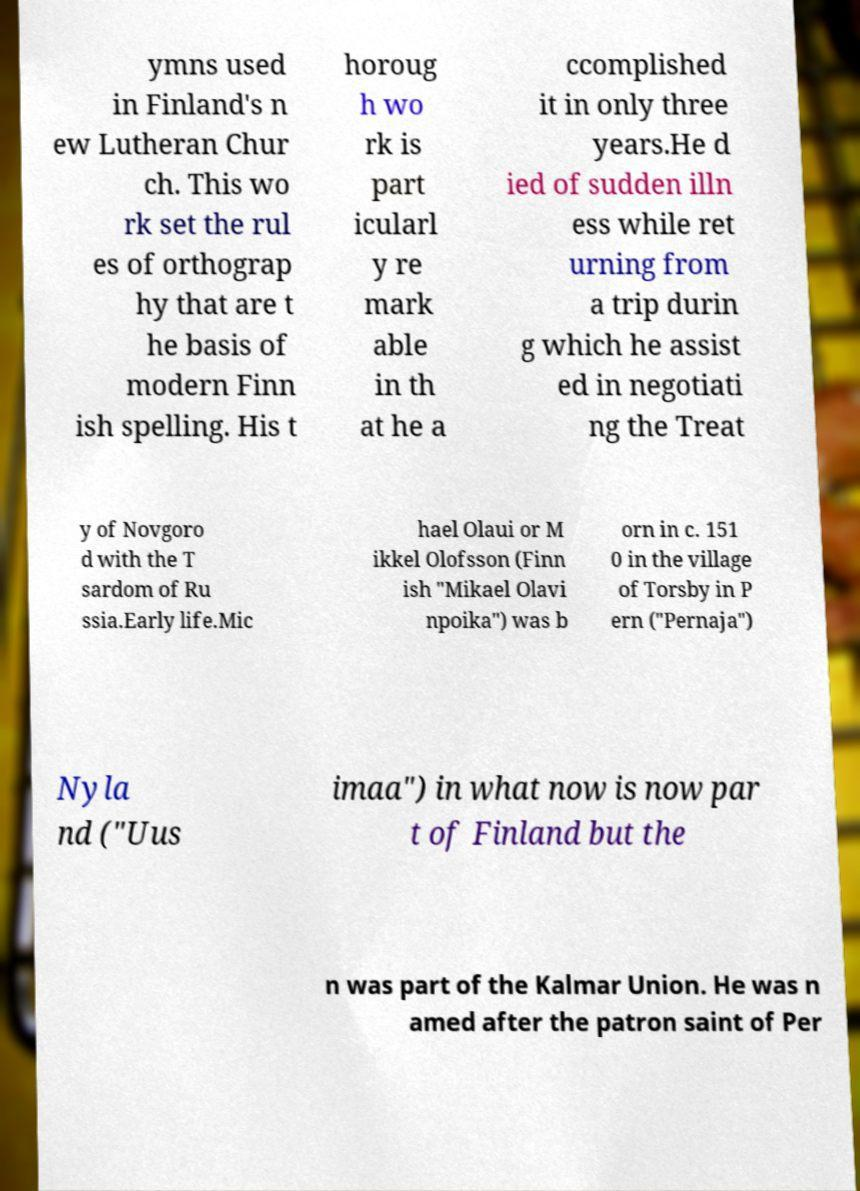Can you accurately transcribe the text from the provided image for me? ymns used in Finland's n ew Lutheran Chur ch. This wo rk set the rul es of orthograp hy that are t he basis of modern Finn ish spelling. His t horoug h wo rk is part icularl y re mark able in th at he a ccomplished it in only three years.He d ied of sudden illn ess while ret urning from a trip durin g which he assist ed in negotiati ng the Treat y of Novgoro d with the T sardom of Ru ssia.Early life.Mic hael Olaui or M ikkel Olofsson (Finn ish "Mikael Olavi npoika") was b orn in c. 151 0 in the village of Torsby in P ern ("Pernaja") Nyla nd ("Uus imaa") in what now is now par t of Finland but the n was part of the Kalmar Union. He was n amed after the patron saint of Per 